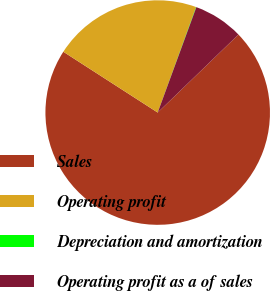Convert chart. <chart><loc_0><loc_0><loc_500><loc_500><pie_chart><fcel>Sales<fcel>Operating profit<fcel>Depreciation and amortization<fcel>Operating profit as a of sales<nl><fcel>71.34%<fcel>21.44%<fcel>0.05%<fcel>7.18%<nl></chart> 